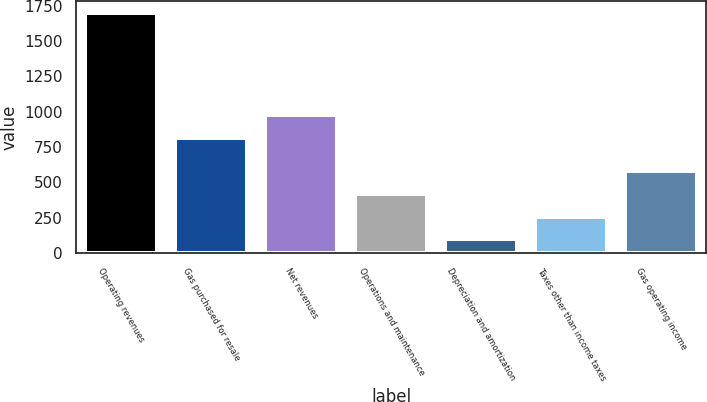Convert chart. <chart><loc_0><loc_0><loc_500><loc_500><bar_chart><fcel>Operating revenues<fcel>Gas purchased for resale<fcel>Net revenues<fcel>Operations and maintenance<fcel>Depreciation and amortization<fcel>Taxes other than income taxes<fcel>Gas operating income<nl><fcel>1701<fcel>818<fcel>978.3<fcel>418.6<fcel>98<fcel>258.3<fcel>578.9<nl></chart> 